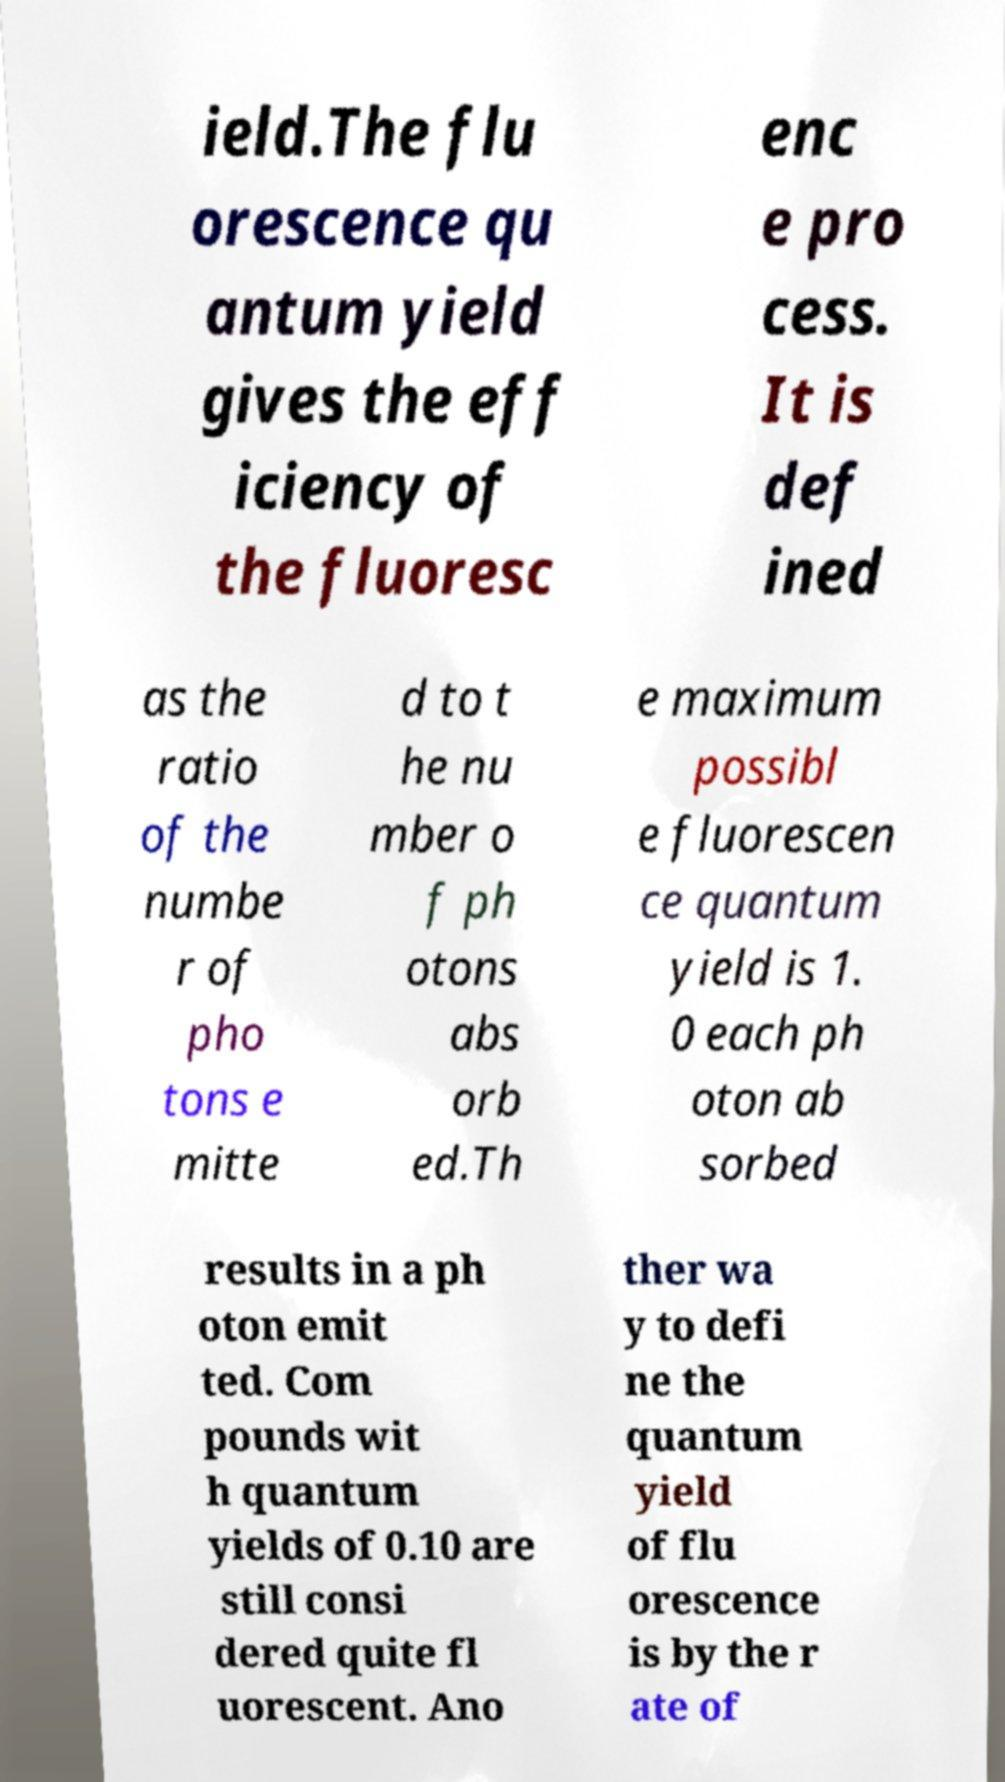What messages or text are displayed in this image? I need them in a readable, typed format. ield.The flu orescence qu antum yield gives the eff iciency of the fluoresc enc e pro cess. It is def ined as the ratio of the numbe r of pho tons e mitte d to t he nu mber o f ph otons abs orb ed.Th e maximum possibl e fluorescen ce quantum yield is 1. 0 each ph oton ab sorbed results in a ph oton emit ted. Com pounds wit h quantum yields of 0.10 are still consi dered quite fl uorescent. Ano ther wa y to defi ne the quantum yield of flu orescence is by the r ate of 